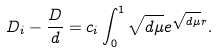<formula> <loc_0><loc_0><loc_500><loc_500>D _ { i } - \frac { D } { d } = c _ { i } \int _ { 0 } ^ { 1 } \sqrt { d \mu } e ^ { \sqrt { d \mu } r } .</formula> 